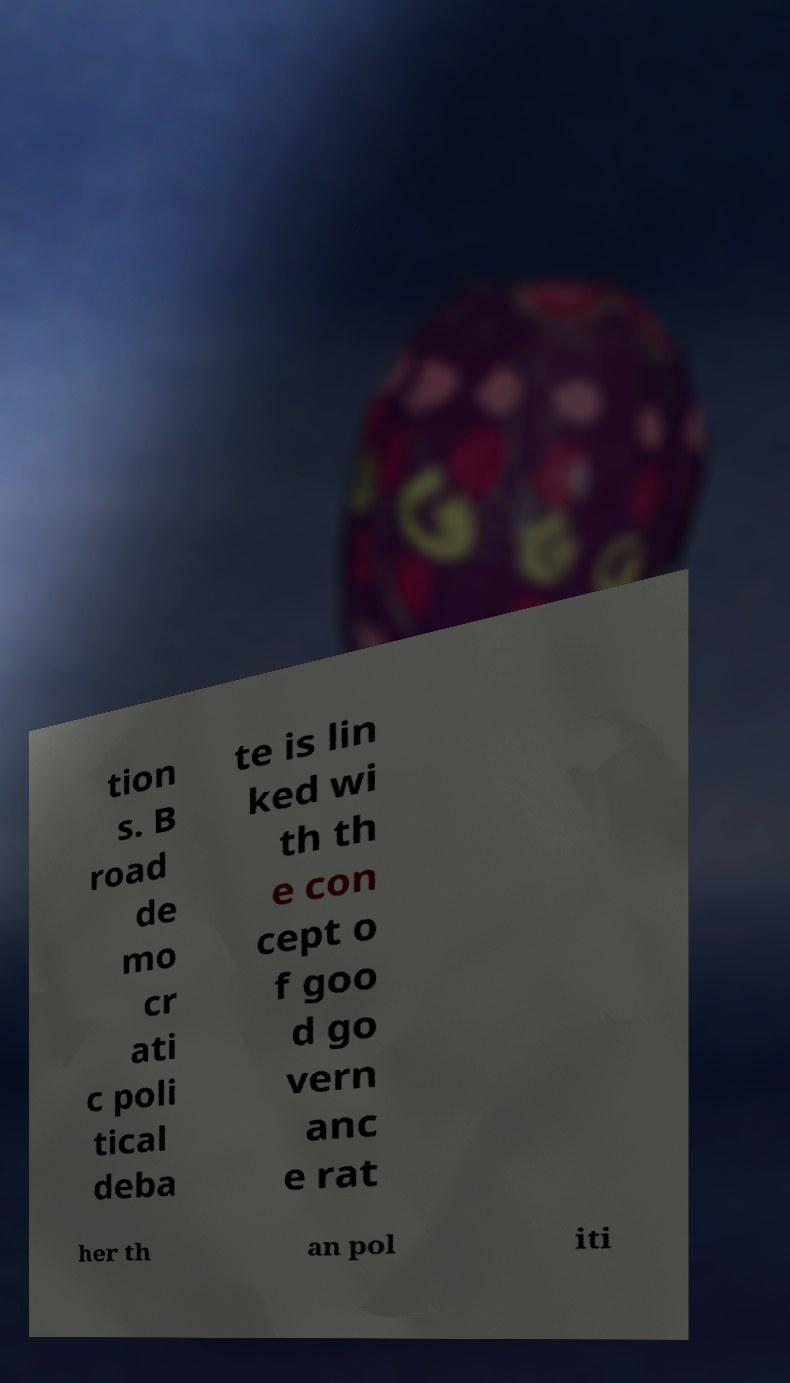There's text embedded in this image that I need extracted. Can you transcribe it verbatim? tion s. B road de mo cr ati c poli tical deba te is lin ked wi th th e con cept o f goo d go vern anc e rat her th an pol iti 